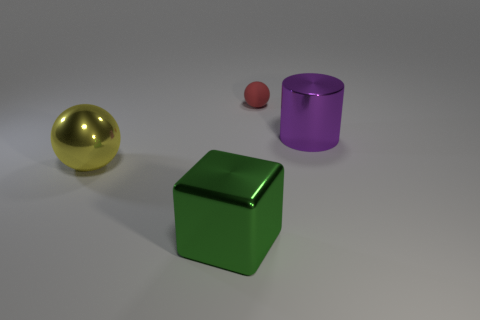Add 2 green shiny cylinders. How many objects exist? 6 Subtract 1 yellow spheres. How many objects are left? 3 Subtract all cylinders. How many objects are left? 3 Subtract all tiny blue matte blocks. Subtract all metallic blocks. How many objects are left? 3 Add 4 red matte balls. How many red matte balls are left? 5 Add 4 small purple matte spheres. How many small purple matte spheres exist? 4 